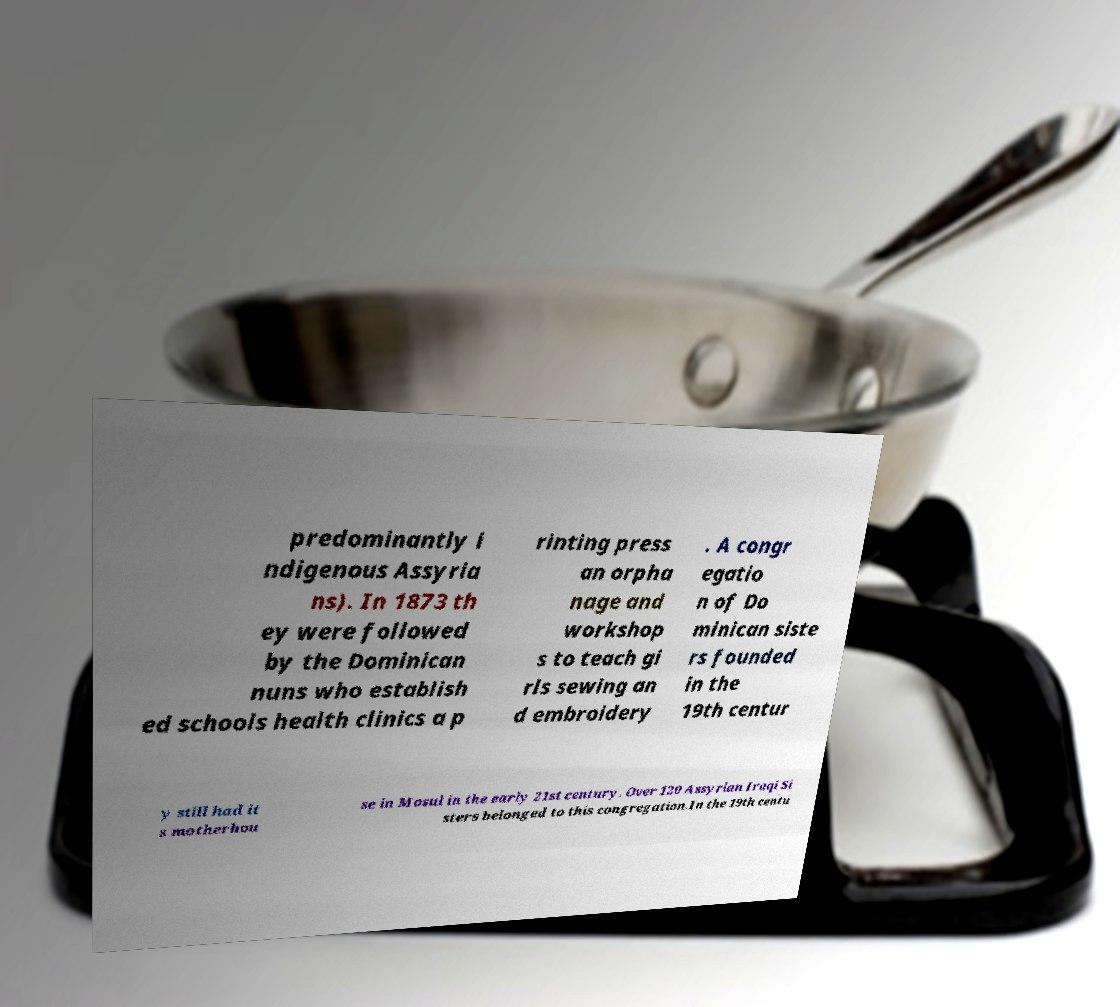Could you assist in decoding the text presented in this image and type it out clearly? predominantly i ndigenous Assyria ns). In 1873 th ey were followed by the Dominican nuns who establish ed schools health clinics a p rinting press an orpha nage and workshop s to teach gi rls sewing an d embroidery . A congr egatio n of Do minican siste rs founded in the 19th centur y still had it s motherhou se in Mosul in the early 21st century. Over 120 Assyrian Iraqi Si sters belonged to this congregation.In the 19th centu 